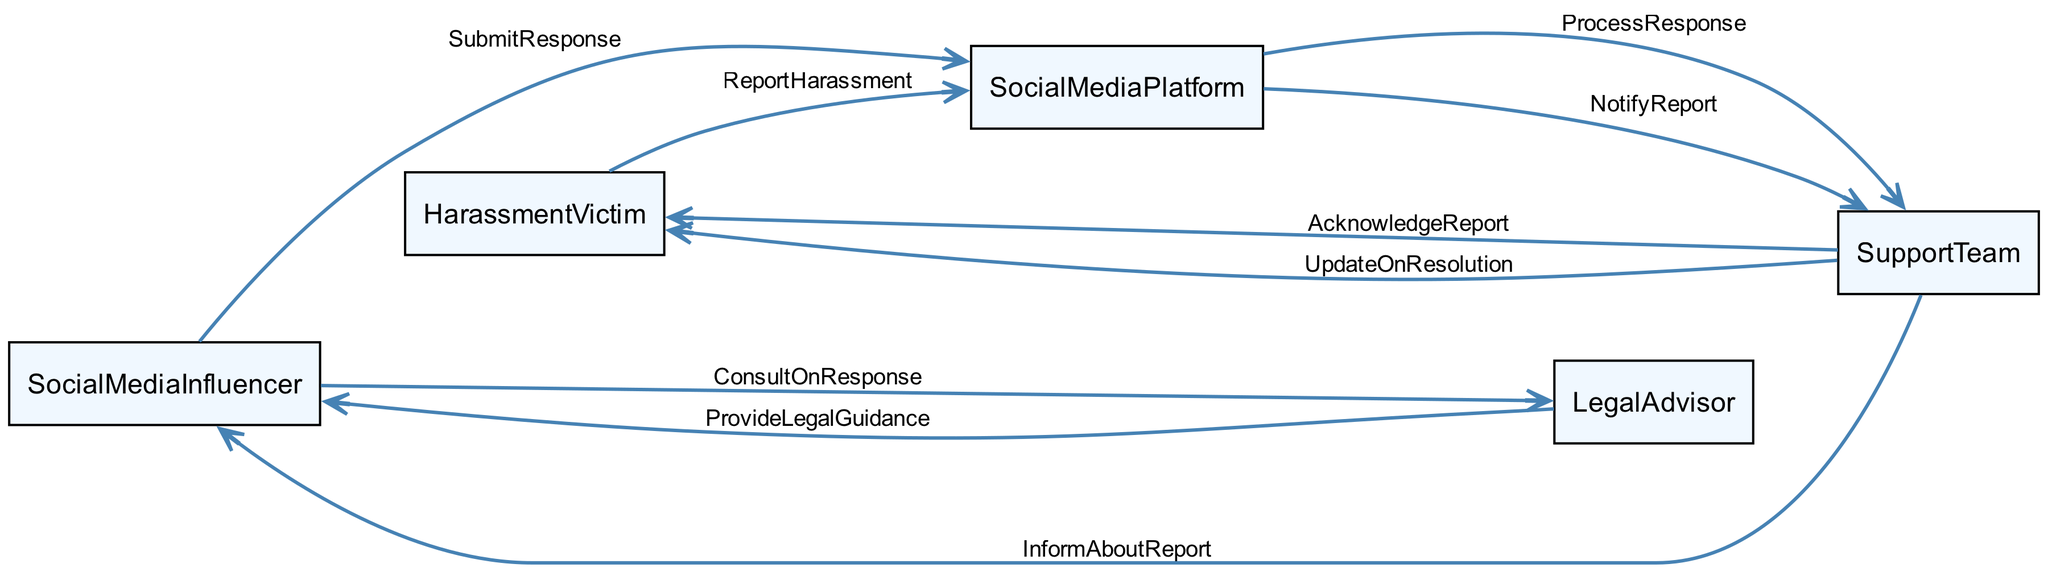What is the first action in the sequence? The first action is initiated by the Harassment Victim who reports the harassment to the Social Media Platform.
Answer: ReportHarassment How many participants are in the diagram? There are five participants shown in the diagram: Social Media Influencer, Harassment Victim, Social Media Platform, Legal Advisor, and Support Team.
Answer: Five Who is informed about the report by the Support Team? The Support Team informs the Social Media Influencer about the report after acknowledging it from the Harassment Victim.
Answer: Social Media Influencer Which participant provides legal guidance? The Legal Advisor provides legal guidance to the Social Media Influencer during the interaction sequence.
Answer: Legal Advisor What action does the Social Media Influencer take after consulting the Legal Advisor? After the consultation, the Social Media Influencer submits a response to the Social Media Platform regarding the harassment report.
Answer: SubmitResponse Explain the flow of information from the Harassment Victim to the Support Team. The Harassment Victim first reports the harassment to the Social Media Platform, which notifies the Support Team. The Support Team subsequently acknowledges the report back to the Harassment Victim.
Answer: Harassment Victim to Social Media Platform to Support Team to Harassment Victim What is the last action in the sequence? The last action is updating the Harassment Victim on the resolution of the report by the Support Team.
Answer: UpdateOnResolution How many actions involve the Support Team? The Support Team is involved in three actions: notifying about the report, acknowledging the report to the Harassment Victim, and updating the Harassment Victim on the resolution.
Answer: Three What type of guidance does the Legal Advisor provide? The Legal Advisor provides legal guidance to help the Social Media Influencer respond appropriately to the harassment report.
Answer: Legal Guidance 